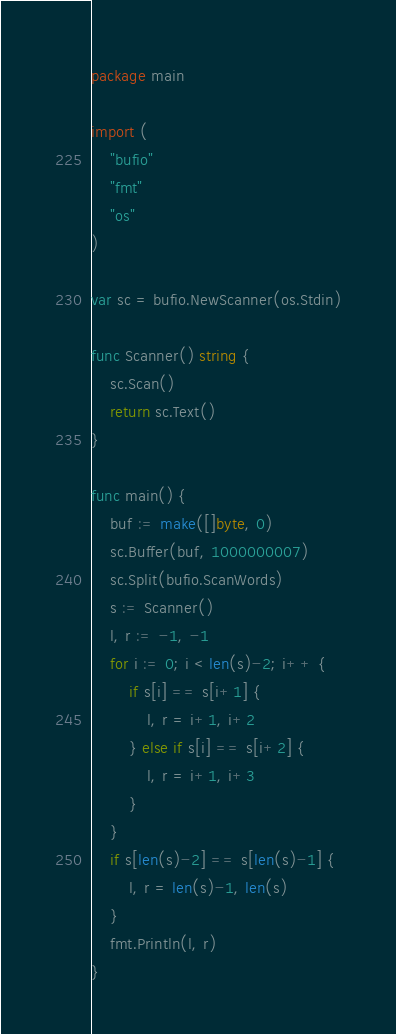Convert code to text. <code><loc_0><loc_0><loc_500><loc_500><_Go_>package main

import (
	"bufio"
	"fmt"
	"os"
)

var sc = bufio.NewScanner(os.Stdin)

func Scanner() string {
	sc.Scan()
	return sc.Text()
}

func main() {
	buf := make([]byte, 0)
	sc.Buffer(buf, 1000000007)
	sc.Split(bufio.ScanWords)
	s := Scanner()
	l, r := -1, -1
	for i := 0; i < len(s)-2; i++ {
		if s[i] == s[i+1] {
			l, r = i+1, i+2
		} else if s[i] == s[i+2] {
			l, r = i+1, i+3
		}
	}
	if s[len(s)-2] == s[len(s)-1] {
		l, r = len(s)-1, len(s)
	}
	fmt.Println(l, r)
}
</code> 